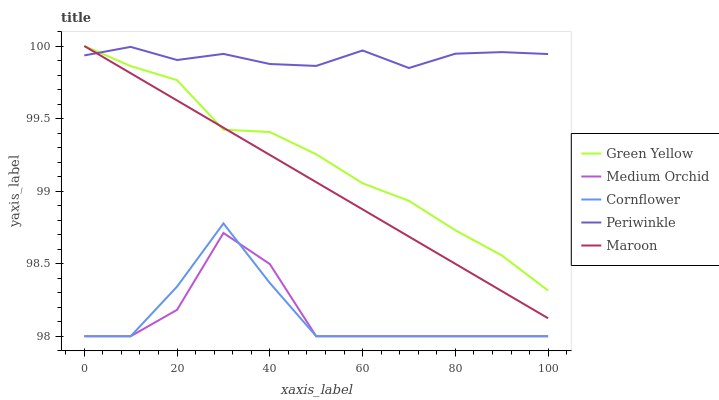Does Medium Orchid have the minimum area under the curve?
Answer yes or no. Yes. Does Periwinkle have the maximum area under the curve?
Answer yes or no. Yes. Does Green Yellow have the minimum area under the curve?
Answer yes or no. No. Does Green Yellow have the maximum area under the curve?
Answer yes or no. No. Is Maroon the smoothest?
Answer yes or no. Yes. Is Medium Orchid the roughest?
Answer yes or no. Yes. Is Green Yellow the smoothest?
Answer yes or no. No. Is Green Yellow the roughest?
Answer yes or no. No. Does Cornflower have the lowest value?
Answer yes or no. Yes. Does Green Yellow have the lowest value?
Answer yes or no. No. Does Maroon have the highest value?
Answer yes or no. Yes. Does Medium Orchid have the highest value?
Answer yes or no. No. Is Medium Orchid less than Green Yellow?
Answer yes or no. Yes. Is Maroon greater than Cornflower?
Answer yes or no. Yes. Does Maroon intersect Periwinkle?
Answer yes or no. Yes. Is Maroon less than Periwinkle?
Answer yes or no. No. Is Maroon greater than Periwinkle?
Answer yes or no. No. Does Medium Orchid intersect Green Yellow?
Answer yes or no. No. 